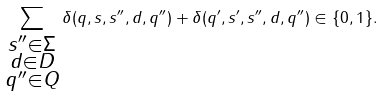Convert formula to latex. <formula><loc_0><loc_0><loc_500><loc_500>\sum _ { \substack { s ^ { \prime \prime } \in \Sigma \\ d \in D \\ q ^ { \prime \prime } \in Q } } \delta ( q , s , s ^ { \prime \prime } , d , q ^ { \prime \prime } ) + \delta ( q ^ { \prime } , s ^ { \prime } , s ^ { \prime \prime } , d , q ^ { \prime \prime } ) \in \{ 0 , 1 \} .</formula> 